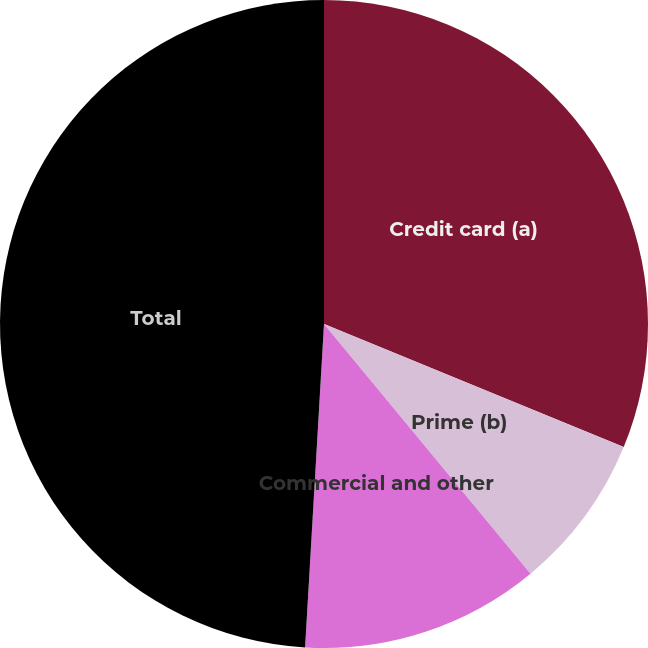Convert chart to OTSL. <chart><loc_0><loc_0><loc_500><loc_500><pie_chart><fcel>Credit card (a)<fcel>Prime (b)<fcel>Commercial and other<fcel>Total<nl><fcel>31.2%<fcel>7.8%<fcel>11.93%<fcel>49.07%<nl></chart> 